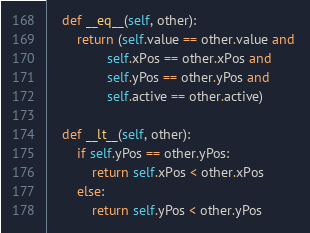Convert code to text. <code><loc_0><loc_0><loc_500><loc_500><_Python_>    def __eq__(self, other):
        return (self.value == other.value and 
                self.xPos == other.xPos and
                self.yPos == other.yPos and
                self.active == other.active)

    def __lt__(self, other):
        if self.yPos == other.yPos:
            return self.xPos < other.xPos
        else:
            return self.yPos < other.yPos
</code> 